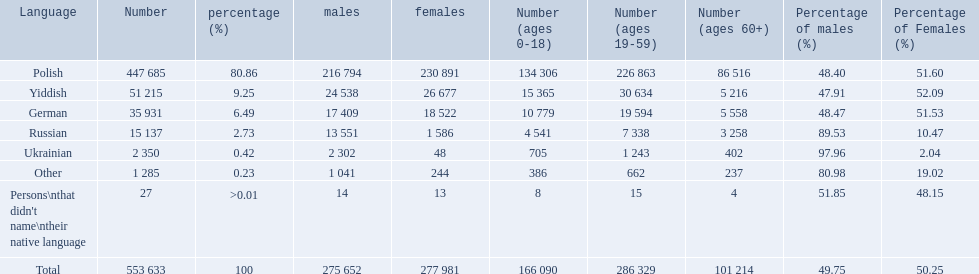Which language options are listed? Polish, Yiddish, German, Russian, Ukrainian, Other, Persons\nthat didn't name\ntheir native language. Of these, which did .42% of the people select? Ukrainian. 